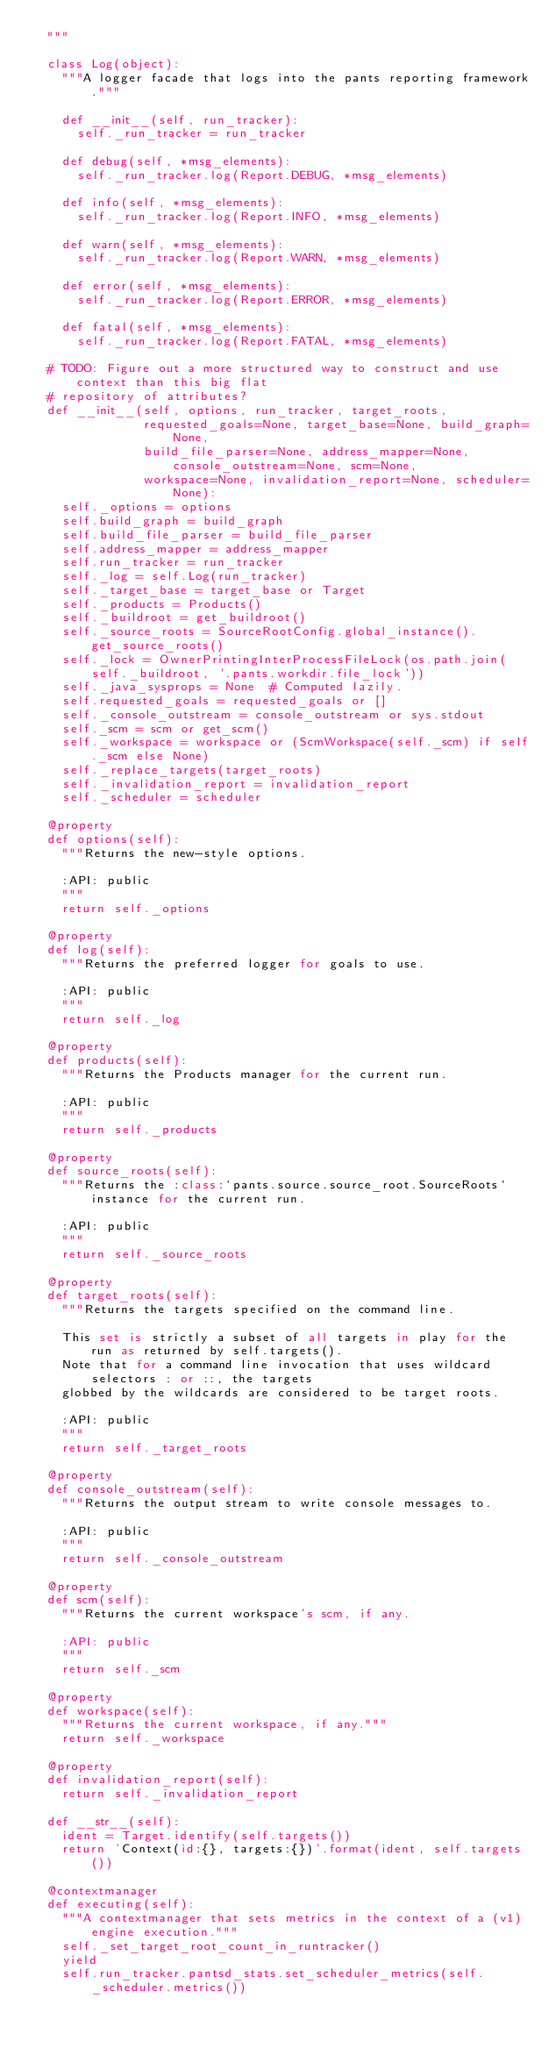Convert code to text. <code><loc_0><loc_0><loc_500><loc_500><_Python_>  """

  class Log(object):
    """A logger facade that logs into the pants reporting framework."""

    def __init__(self, run_tracker):
      self._run_tracker = run_tracker

    def debug(self, *msg_elements):
      self._run_tracker.log(Report.DEBUG, *msg_elements)

    def info(self, *msg_elements):
      self._run_tracker.log(Report.INFO, *msg_elements)

    def warn(self, *msg_elements):
      self._run_tracker.log(Report.WARN, *msg_elements)

    def error(self, *msg_elements):
      self._run_tracker.log(Report.ERROR, *msg_elements)

    def fatal(self, *msg_elements):
      self._run_tracker.log(Report.FATAL, *msg_elements)

  # TODO: Figure out a more structured way to construct and use context than this big flat
  # repository of attributes?
  def __init__(self, options, run_tracker, target_roots,
               requested_goals=None, target_base=None, build_graph=None,
               build_file_parser=None, address_mapper=None, console_outstream=None, scm=None,
               workspace=None, invalidation_report=None, scheduler=None):
    self._options = options
    self.build_graph = build_graph
    self.build_file_parser = build_file_parser
    self.address_mapper = address_mapper
    self.run_tracker = run_tracker
    self._log = self.Log(run_tracker)
    self._target_base = target_base or Target
    self._products = Products()
    self._buildroot = get_buildroot()
    self._source_roots = SourceRootConfig.global_instance().get_source_roots()
    self._lock = OwnerPrintingInterProcessFileLock(os.path.join(self._buildroot, '.pants.workdir.file_lock'))
    self._java_sysprops = None  # Computed lazily.
    self.requested_goals = requested_goals or []
    self._console_outstream = console_outstream or sys.stdout
    self._scm = scm or get_scm()
    self._workspace = workspace or (ScmWorkspace(self._scm) if self._scm else None)
    self._replace_targets(target_roots)
    self._invalidation_report = invalidation_report
    self._scheduler = scheduler

  @property
  def options(self):
    """Returns the new-style options.

    :API: public
    """
    return self._options

  @property
  def log(self):
    """Returns the preferred logger for goals to use.

    :API: public
    """
    return self._log

  @property
  def products(self):
    """Returns the Products manager for the current run.

    :API: public
    """
    return self._products

  @property
  def source_roots(self):
    """Returns the :class:`pants.source.source_root.SourceRoots` instance for the current run.

    :API: public
    """
    return self._source_roots

  @property
  def target_roots(self):
    """Returns the targets specified on the command line.

    This set is strictly a subset of all targets in play for the run as returned by self.targets().
    Note that for a command line invocation that uses wildcard selectors : or ::, the targets
    globbed by the wildcards are considered to be target roots.

    :API: public
    """
    return self._target_roots

  @property
  def console_outstream(self):
    """Returns the output stream to write console messages to.

    :API: public
    """
    return self._console_outstream

  @property
  def scm(self):
    """Returns the current workspace's scm, if any.

    :API: public
    """
    return self._scm

  @property
  def workspace(self):
    """Returns the current workspace, if any."""
    return self._workspace

  @property
  def invalidation_report(self):
    return self._invalidation_report

  def __str__(self):
    ident = Target.identify(self.targets())
    return 'Context(id:{}, targets:{})'.format(ident, self.targets())

  @contextmanager
  def executing(self):
    """A contextmanager that sets metrics in the context of a (v1) engine execution."""
    self._set_target_root_count_in_runtracker()
    yield
    self.run_tracker.pantsd_stats.set_scheduler_metrics(self._scheduler.metrics())</code> 